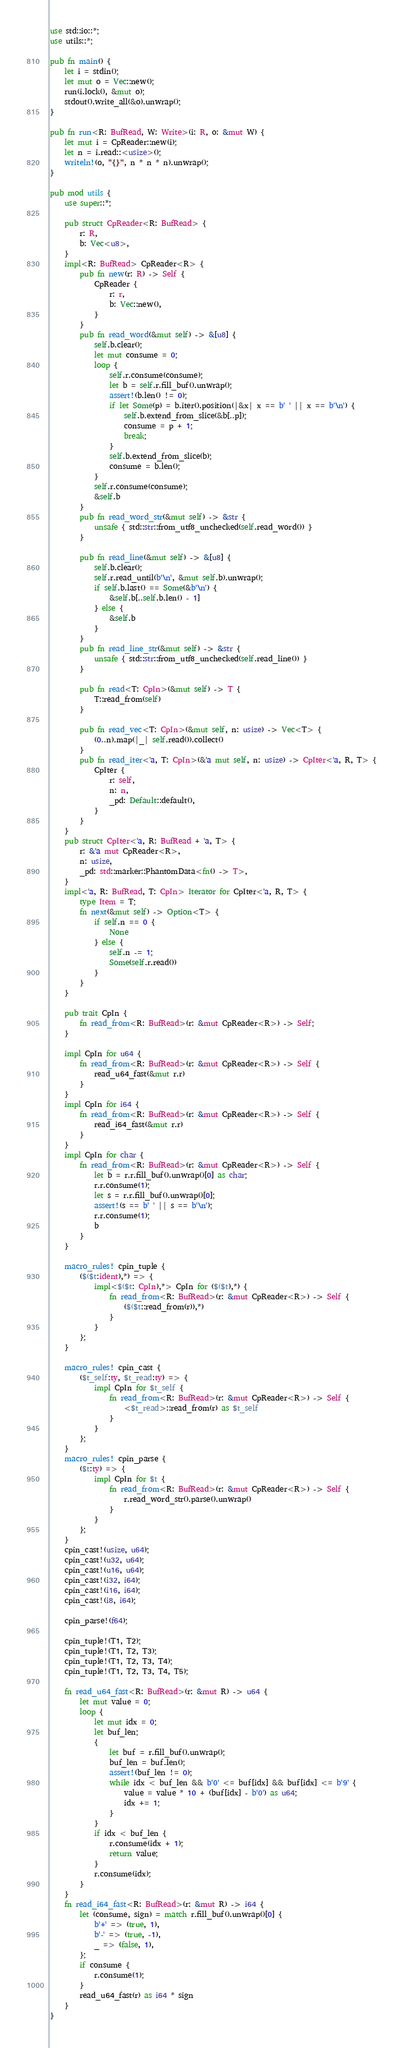Convert code to text. <code><loc_0><loc_0><loc_500><loc_500><_Rust_>use std::io::*;
use utils::*;

pub fn main() {
    let i = stdin();
    let mut o = Vec::new();
    run(i.lock(), &mut o);
    stdout().write_all(&o).unwrap();
}

pub fn run<R: BufRead, W: Write>(i: R, o: &mut W) {
    let mut i = CpReader::new(i);
    let n = i.read::<usize>();
    writeln!(o, "{}", n * n * n).unwrap();
}

pub mod utils {
    use super::*;

    pub struct CpReader<R: BufRead> {
        r: R,
        b: Vec<u8>,
    }
    impl<R: BufRead> CpReader<R> {
        pub fn new(r: R) -> Self {
            CpReader {
                r: r,
                b: Vec::new(),
            }
        }
        pub fn read_word(&mut self) -> &[u8] {
            self.b.clear();
            let mut consume = 0;
            loop {
                self.r.consume(consume);
                let b = self.r.fill_buf().unwrap();
                assert!(b.len() != 0);
                if let Some(p) = b.iter().position(|&x| x == b' ' || x == b'\n') {
                    self.b.extend_from_slice(&b[..p]);
                    consume = p + 1;
                    break;
                }
                self.b.extend_from_slice(b);
                consume = b.len();
            }
            self.r.consume(consume);
            &self.b
        }
        pub fn read_word_str(&mut self) -> &str {
            unsafe { std::str::from_utf8_unchecked(self.read_word()) }
        }

        pub fn read_line(&mut self) -> &[u8] {
            self.b.clear();
            self.r.read_until(b'\n', &mut self.b).unwrap();
            if self.b.last() == Some(&b'\n') {
                &self.b[..self.b.len() - 1]
            } else {
                &self.b
            }
        }
        pub fn read_line_str(&mut self) -> &str {
            unsafe { std::str::from_utf8_unchecked(self.read_line()) }
        }

        pub fn read<T: CpIn>(&mut self) -> T {
            T::read_from(self)
        }

        pub fn read_vec<T: CpIn>(&mut self, n: usize) -> Vec<T> {
            (0..n).map(|_| self.read()).collect()
        }
        pub fn read_iter<'a, T: CpIn>(&'a mut self, n: usize) -> CpIter<'a, R, T> {
            CpIter {
                r: self,
                n: n,
                _pd: Default::default(),
            }
        }
    }
    pub struct CpIter<'a, R: BufRead + 'a, T> {
        r: &'a mut CpReader<R>,
        n: usize,
        _pd: std::marker::PhantomData<fn() -> T>,
    }
    impl<'a, R: BufRead, T: CpIn> Iterator for CpIter<'a, R, T> {
        type Item = T;
        fn next(&mut self) -> Option<T> {
            if self.n == 0 {
                None
            } else {
                self.n -= 1;
                Some(self.r.read())
            }
        }
    }

    pub trait CpIn {
        fn read_from<R: BufRead>(r: &mut CpReader<R>) -> Self;
    }

    impl CpIn for u64 {
        fn read_from<R: BufRead>(r: &mut CpReader<R>) -> Self {
            read_u64_fast(&mut r.r)
        }
    }
    impl CpIn for i64 {
        fn read_from<R: BufRead>(r: &mut CpReader<R>) -> Self {
            read_i64_fast(&mut r.r)
        }
    }
    impl CpIn for char {
        fn read_from<R: BufRead>(r: &mut CpReader<R>) -> Self {
            let b = r.r.fill_buf().unwrap()[0] as char;
            r.r.consume(1);
            let s = r.r.fill_buf().unwrap()[0];
            assert!(s == b' ' || s == b'\n');
            r.r.consume(1);
            b
        }
    }

    macro_rules! cpin_tuple {
        ($($t:ident),*) => {
            impl<$($t: CpIn),*> CpIn for ($($t),*) {
                fn read_from<R: BufRead>(r: &mut CpReader<R>) -> Self {
                    ($($t::read_from(r)),*)
                }
            }
        };
    }

    macro_rules! cpin_cast {
        ($t_self:ty, $t_read:ty) => {
            impl CpIn for $t_self {
                fn read_from<R: BufRead>(r: &mut CpReader<R>) -> Self {
                    <$t_read>::read_from(r) as $t_self
                }
            }
        };
    }
    macro_rules! cpin_parse {
        ($t:ty) => {
            impl CpIn for $t {
                fn read_from<R: BufRead>(r: &mut CpReader<R>) -> Self {
                    r.read_word_str().parse().unwrap()
                }
            }
        };
    }
    cpin_cast!(usize, u64);
    cpin_cast!(u32, u64);
    cpin_cast!(u16, u64);
    cpin_cast!(i32, i64);
    cpin_cast!(i16, i64);
    cpin_cast!(i8, i64);

    cpin_parse!(f64);

    cpin_tuple!(T1, T2);
    cpin_tuple!(T1, T2, T3);
    cpin_tuple!(T1, T2, T3, T4);
    cpin_tuple!(T1, T2, T3, T4, T5);

    fn read_u64_fast<R: BufRead>(r: &mut R) -> u64 {
        let mut value = 0;
        loop {
            let mut idx = 0;
            let buf_len;
            {
                let buf = r.fill_buf().unwrap();
                buf_len = buf.len();
                assert!(buf_len != 0);
                while idx < buf_len && b'0' <= buf[idx] && buf[idx] <= b'9' {
                    value = value * 10 + (buf[idx] - b'0') as u64;
                    idx += 1;
                }
            }
            if idx < buf_len {
                r.consume(idx + 1);
                return value;
            }
            r.consume(idx);
        }
    }
    fn read_i64_fast<R: BufRead>(r: &mut R) -> i64 {
        let (consume, sign) = match r.fill_buf().unwrap()[0] {
            b'+' => (true, 1),
            b'-' => (true, -1),
            _ => (false, 1),
        };
        if consume {
            r.consume(1);
        }
        read_u64_fast(r) as i64 * sign
    }
}
</code> 